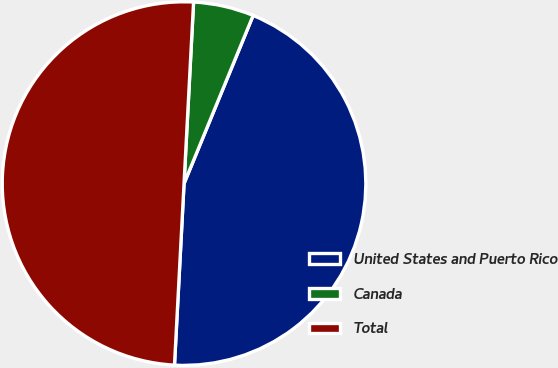Convert chart to OTSL. <chart><loc_0><loc_0><loc_500><loc_500><pie_chart><fcel>United States and Puerto Rico<fcel>Canada<fcel>Total<nl><fcel>44.63%<fcel>5.37%<fcel>50.0%<nl></chart> 